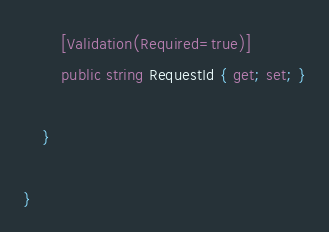<code> <loc_0><loc_0><loc_500><loc_500><_C#_>        [Validation(Required=true)]
        public string RequestId { get; set; }

    }

}
</code> 